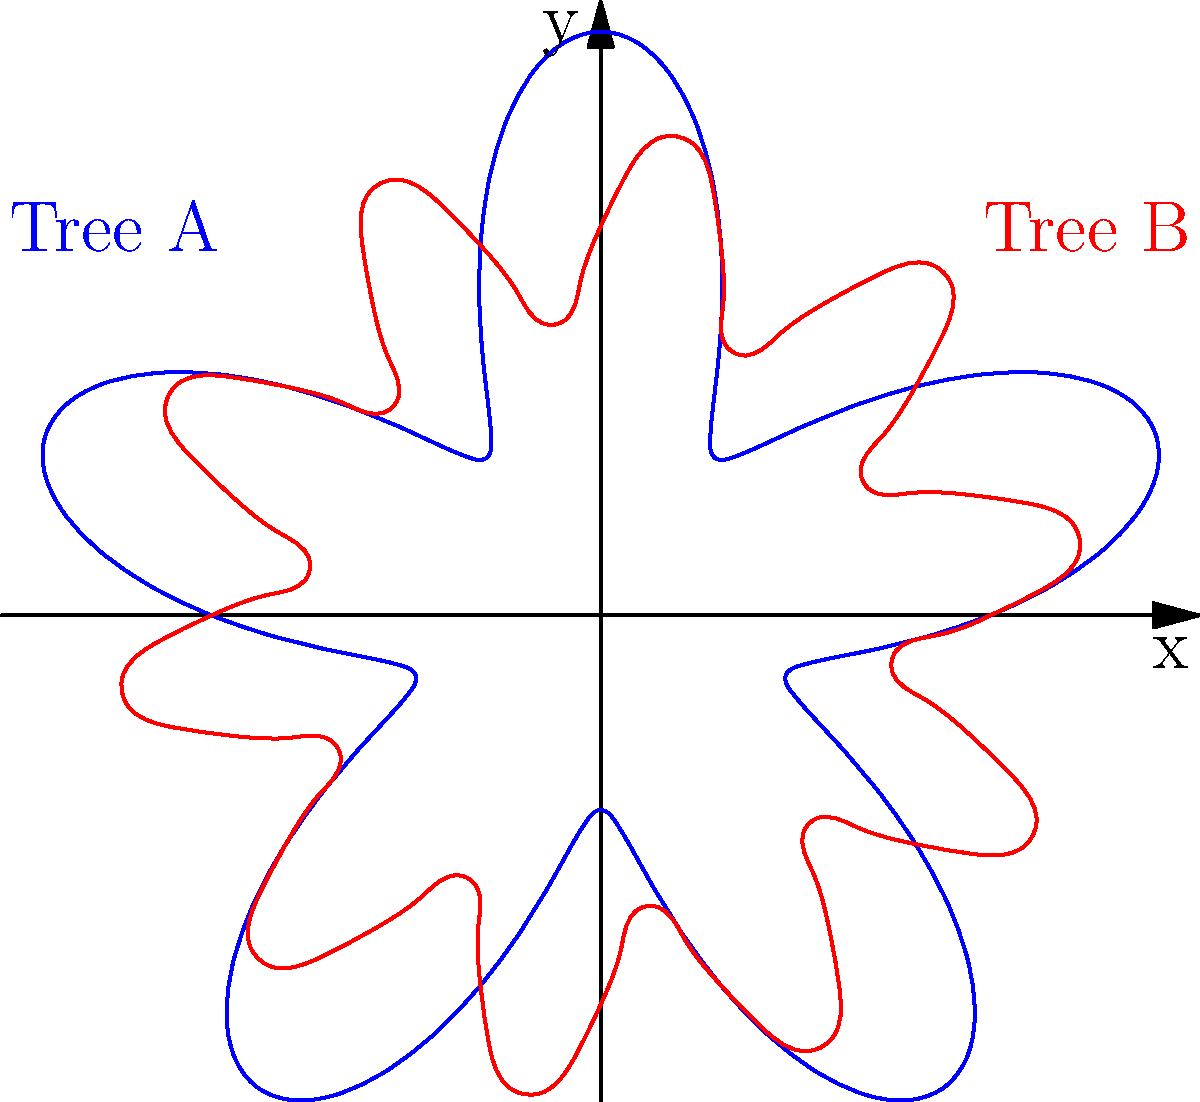The polar graphs above represent the tree ring growth patterns of two different trees over a 12-year period. The distance from the origin represents the width of each ring, and the angle represents the year (with a complete revolution being 12 years). If the blue graph (Tree A) has a maximum ring width of 3 units, what is the approximate maximum ring width for the red graph (Tree B)? To solve this problem, we need to follow these steps:

1. Analyze the blue graph (Tree A):
   - The equation for Tree A is $r = 2 + \sin(5\theta)$
   - The maximum value occurs when $\sin(5\theta) = 1$
   - Therefore, the maximum ring width for Tree A is $2 + 1 = 3$ units

2. Analyze the red graph (Tree B):
   - The equation for Tree B is $r = 2 + 0.5\sin(10\theta)$
   - The maximum value occurs when $\sin(10\theta) = 1$
   - Therefore, the maximum ring width for Tree B is $2 + 0.5 = 2.5$ units

3. Compare the maximum ring widths:
   - Tree A: 3 units
   - Tree B: 2.5 units

4. Calculate the ratio:
   $\frac{\text{Tree B max}}{\text{Tree A max}} = \frac{2.5}{3} \approx 0.833$

Therefore, the maximum ring width for Tree B is approximately 0.833 times the maximum ring width of Tree A, or 2.5 units.
Answer: 2.5 units 